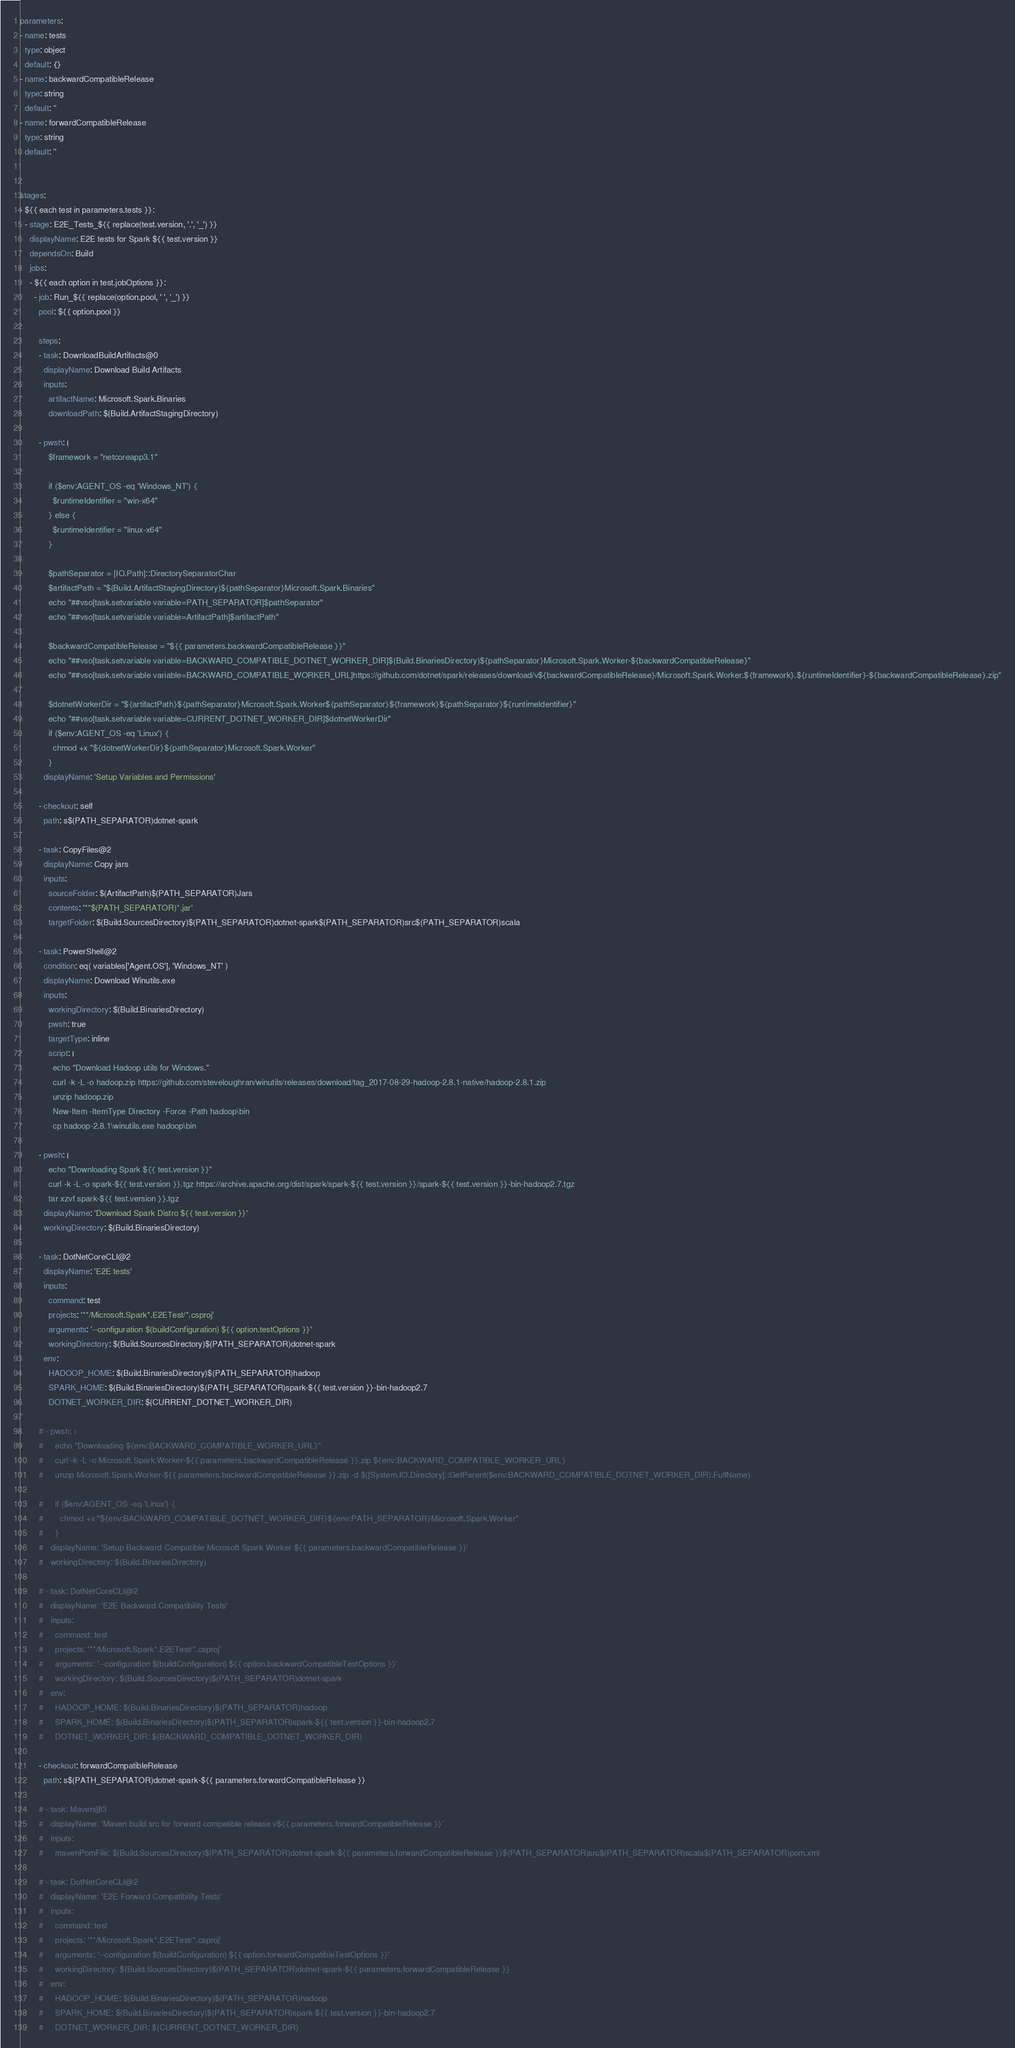Convert code to text. <code><loc_0><loc_0><loc_500><loc_500><_YAML_>parameters:
- name: tests
  type: object
  default: {}
- name: backwardCompatibleRelease
  type: string
  default: ''
- name: forwardCompatibleRelease
  type: string
  default: ''


stages:
- ${{ each test in parameters.tests }}:
  - stage: E2E_Tests_${{ replace(test.version, '.', '_') }}
    displayName: E2E tests for Spark ${{ test.version }}
    dependsOn: Build
    jobs:
    - ${{ each option in test.jobOptions }}:
      - job: Run_${{ replace(option.pool, ' ', '_') }}
        pool: ${{ option.pool }}

        steps:
        - task: DownloadBuildArtifacts@0
          displayName: Download Build Artifacts
          inputs:
            artifactName: Microsoft.Spark.Binaries
            downloadPath: $(Build.ArtifactStagingDirectory)

        - pwsh: |
            $framework = "netcoreapp3.1"

            if ($env:AGENT_OS -eq 'Windows_NT') {
              $runtimeIdentifier = "win-x64"
            } else {
              $runtimeIdentifier = "linux-x64"
            }

            $pathSeparator = [IO.Path]::DirectorySeparatorChar
            $artifactPath = "$(Build.ArtifactStagingDirectory)${pathSeparator}Microsoft.Spark.Binaries"
            echo "##vso[task.setvariable variable=PATH_SEPARATOR]$pathSeparator"
            echo "##vso[task.setvariable variable=ArtifactPath]$artifactPath"

            $backwardCompatibleRelease = "${{ parameters.backwardCompatibleRelease }}"
            echo "##vso[task.setvariable variable=BACKWARD_COMPATIBLE_DOTNET_WORKER_DIR]$(Build.BinariesDirectory)${pathSeparator}Microsoft.Spark.Worker-${backwardCompatibleRelease}"
            echo "##vso[task.setvariable variable=BACKWARD_COMPATIBLE_WORKER_URL]https://github.com/dotnet/spark/releases/download/v${backwardCompatibleRelease}/Microsoft.Spark.Worker.${framework}.${runtimeIdentifier}-${backwardCompatibleRelease}.zip"

            $dotnetWorkerDir = "${artifactPath}${pathSeparator}Microsoft.Spark.Worker${pathSeparator}${framework}${pathSeparator}${runtimeIdentifier}"
            echo "##vso[task.setvariable variable=CURRENT_DOTNET_WORKER_DIR]$dotnetWorkerDir"
            if ($env:AGENT_OS -eq 'Linux') {
              chmod +x "${dotnetWorkerDir}${pathSeparator}Microsoft.Spark.Worker"
            }
          displayName: 'Setup Variables and Permissions'

        - checkout: self
          path: s$(PATH_SEPARATOR)dotnet-spark

        - task: CopyFiles@2
          displayName: Copy jars
          inputs:
            sourceFolder: $(ArtifactPath)$(PATH_SEPARATOR)Jars
            contents: '**$(PATH_SEPARATOR)*.jar'
            targetFolder: $(Build.SourcesDirectory)$(PATH_SEPARATOR)dotnet-spark$(PATH_SEPARATOR)src$(PATH_SEPARATOR)scala

        - task: PowerShell@2
          condition: eq( variables['Agent.OS'], 'Windows_NT' )
          displayName: Download Winutils.exe
          inputs:
            workingDirectory: $(Build.BinariesDirectory)
            pwsh: true
            targetType: inline
            script: |
              echo "Download Hadoop utils for Windows."
              curl -k -L -o hadoop.zip https://github.com/steveloughran/winutils/releases/download/tag_2017-08-29-hadoop-2.8.1-native/hadoop-2.8.1.zip
              unzip hadoop.zip
              New-Item -ItemType Directory -Force -Path hadoop\bin
              cp hadoop-2.8.1\winutils.exe hadoop\bin

        - pwsh: |
            echo "Downloading Spark ${{ test.version }}"
            curl -k -L -o spark-${{ test.version }}.tgz https://archive.apache.org/dist/spark/spark-${{ test.version }}/spark-${{ test.version }}-bin-hadoop2.7.tgz
            tar xzvf spark-${{ test.version }}.tgz
          displayName: 'Download Spark Distro ${{ test.version }}'
          workingDirectory: $(Build.BinariesDirectory)

        - task: DotNetCoreCLI@2
          displayName: 'E2E tests'
          inputs:
            command: test
            projects: '**/Microsoft.Spark*.E2ETest/*.csproj'
            arguments: '--configuration $(buildConfiguration) ${{ option.testOptions }}'
            workingDirectory: $(Build.SourcesDirectory)$(PATH_SEPARATOR)dotnet-spark
          env:
            HADOOP_HOME: $(Build.BinariesDirectory)$(PATH_SEPARATOR)hadoop
            SPARK_HOME: $(Build.BinariesDirectory)$(PATH_SEPARATOR)spark-${{ test.version }}-bin-hadoop2.7
            DOTNET_WORKER_DIR: $(CURRENT_DOTNET_WORKER_DIR)

        # - pwsh: |
        #     echo "Downloading ${env:BACKWARD_COMPATIBLE_WORKER_URL}"
        #     curl -k -L -o Microsoft.Spark.Worker-${{ parameters.backwardCompatibleRelease }}.zip ${env:BACKWARD_COMPATIBLE_WORKER_URL}
        #     unzip Microsoft.Spark.Worker-${{ parameters.backwardCompatibleRelease }}.zip -d $([System.IO.Directory]::GetParent($env:BACKWARD_COMPATIBLE_DOTNET_WORKER_DIR).FullName)

        #     if ($env:AGENT_OS -eq 'Linux') {
        #       chmod +x "${env:BACKWARD_COMPATIBLE_DOTNET_WORKER_DIR}${env:PATH_SEPARATOR}Microsoft.Spark.Worker"
        #     }
        #   displayName: 'Setup Backward Compatible Microsoft Spark Worker ${{ parameters.backwardCompatibleRelease }}'
        #   workingDirectory: $(Build.BinariesDirectory)

        # - task: DotNetCoreCLI@2
        #   displayName: 'E2E Backward Compatibility Tests'
        #   inputs:
        #     command: test
        #     projects: '**/Microsoft.Spark*.E2ETest/*.csproj'
        #     arguments: '--configuration $(buildConfiguration) ${{ option.backwardCompatibleTestOptions }}'
        #     workingDirectory: $(Build.SourcesDirectory)$(PATH_SEPARATOR)dotnet-spark
        #   env:
        #     HADOOP_HOME: $(Build.BinariesDirectory)$(PATH_SEPARATOR)hadoop
        #     SPARK_HOME: $(Build.BinariesDirectory)$(PATH_SEPARATOR)spark-${{ test.version }}-bin-hadoop2.7
        #     DOTNET_WORKER_DIR: $(BACKWARD_COMPATIBLE_DOTNET_WORKER_DIR)

        - checkout: forwardCompatibleRelease
          path: s$(PATH_SEPARATOR)dotnet-spark-${{ parameters.forwardCompatibleRelease }}

        # - task: Maven@3
        #   displayName: 'Maven build src for forward compatible release v${{ parameters.forwardCompatibleRelease }}'
        #   inputs:
        #     mavenPomFile: $(Build.SourcesDirectory)$(PATH_SEPARATOR)dotnet-spark-${{ parameters.forwardCompatibleRelease }}$(PATH_SEPARATOR)src$(PATH_SEPARATOR)scala$(PATH_SEPARATOR)pom.xml

        # - task: DotNetCoreCLI@2
        #   displayName: 'E2E Forward Compatibility Tests'
        #   inputs:
        #     command: test
        #     projects: '**/Microsoft.Spark*.E2ETest/*.csproj'
        #     arguments: '--configuration $(buildConfiguration) ${{ option.forwardCompatibleTestOptions }}'
        #     workingDirectory: $(Build.SourcesDirectory)$(PATH_SEPARATOR)dotnet-spark-${{ parameters.forwardCompatibleRelease }}
        #   env:
        #     HADOOP_HOME: $(Build.BinariesDirectory)$(PATH_SEPARATOR)hadoop
        #     SPARK_HOME: $(Build.BinariesDirectory)$(PATH_SEPARATOR)spark-${{ test.version }}-bin-hadoop2.7
        #     DOTNET_WORKER_DIR: $(CURRENT_DOTNET_WORKER_DIR)</code> 